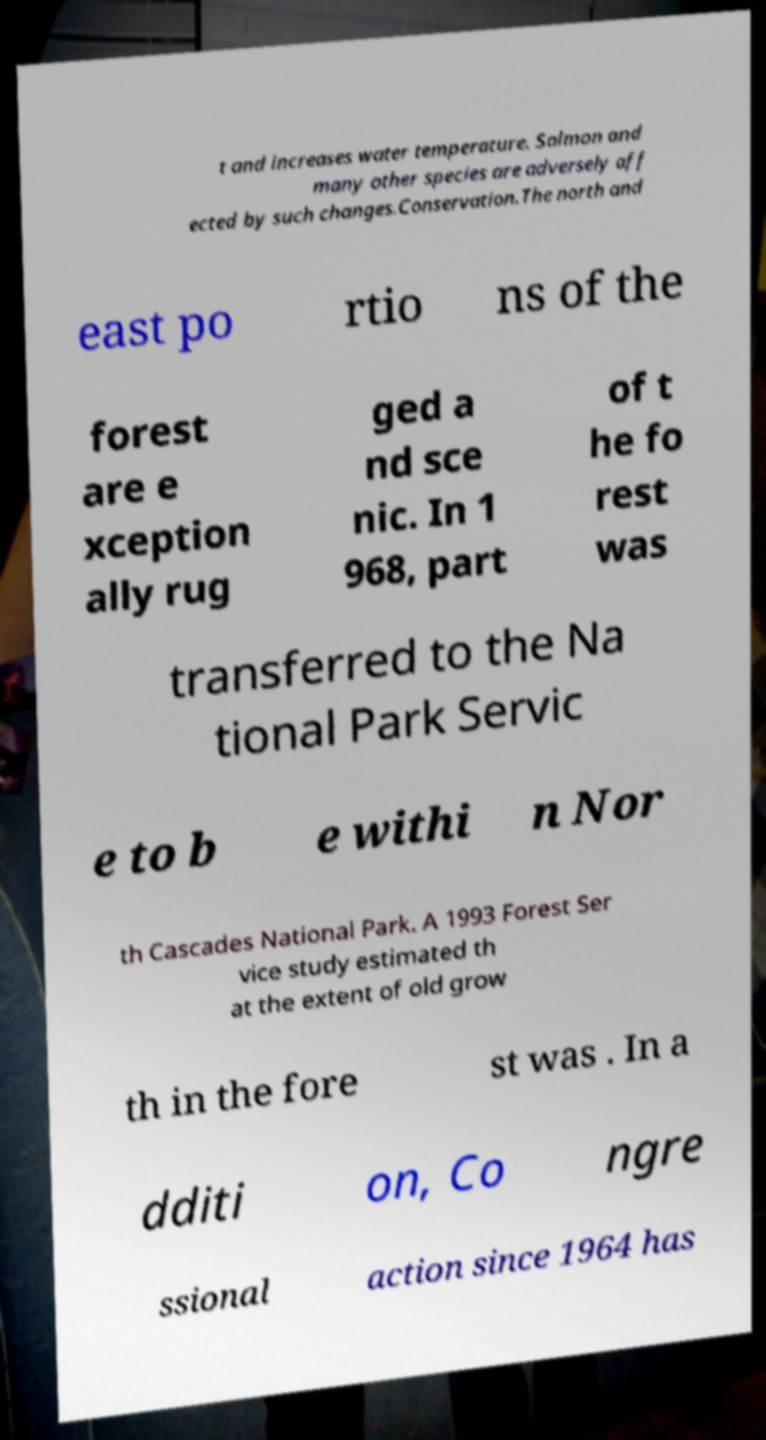There's text embedded in this image that I need extracted. Can you transcribe it verbatim? t and increases water temperature. Salmon and many other species are adversely aff ected by such changes.Conservation.The north and east po rtio ns of the forest are e xception ally rug ged a nd sce nic. In 1 968, part of t he fo rest was transferred to the Na tional Park Servic e to b e withi n Nor th Cascades National Park. A 1993 Forest Ser vice study estimated th at the extent of old grow th in the fore st was . In a dditi on, Co ngre ssional action since 1964 has 